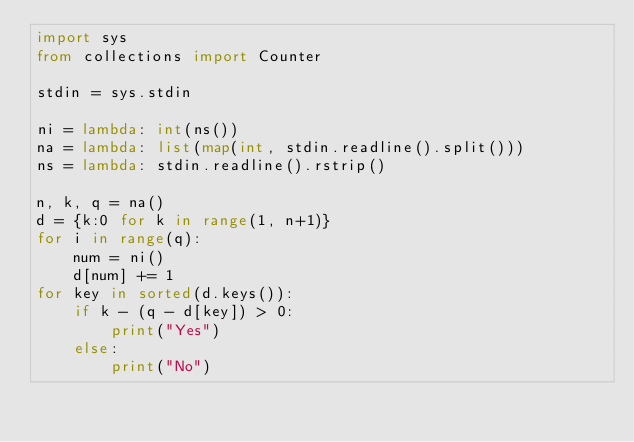<code> <loc_0><loc_0><loc_500><loc_500><_Python_>import sys
from collections import Counter

stdin = sys.stdin

ni = lambda: int(ns())
na = lambda: list(map(int, stdin.readline().split()))
ns = lambda: stdin.readline().rstrip()

n, k, q = na()
d = {k:0 for k in range(1, n+1)}
for i in range(q):
    num = ni()
    d[num] += 1
for key in sorted(d.keys()):
    if k - (q - d[key]) > 0:
        print("Yes")
    else:
        print("No")</code> 